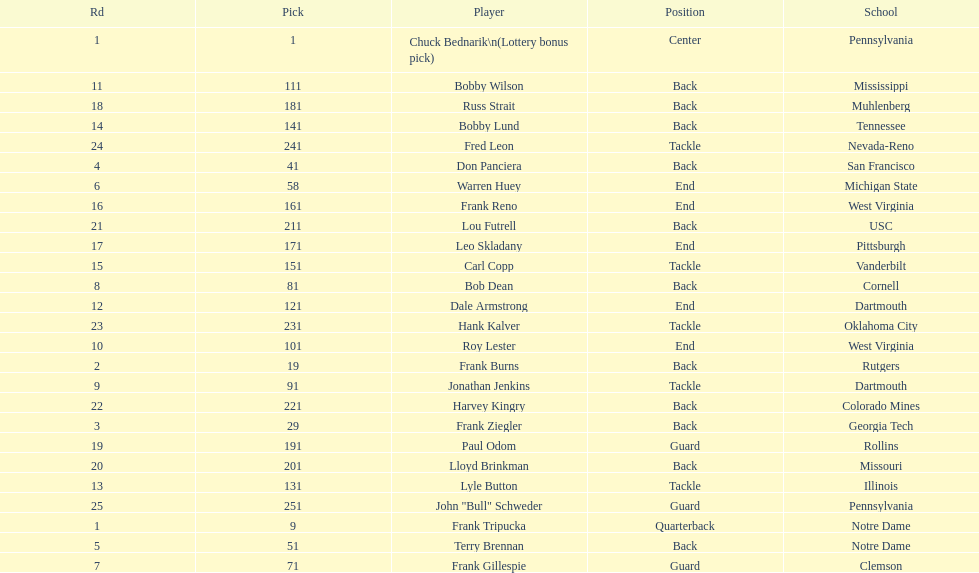Highest rd number? 25. 